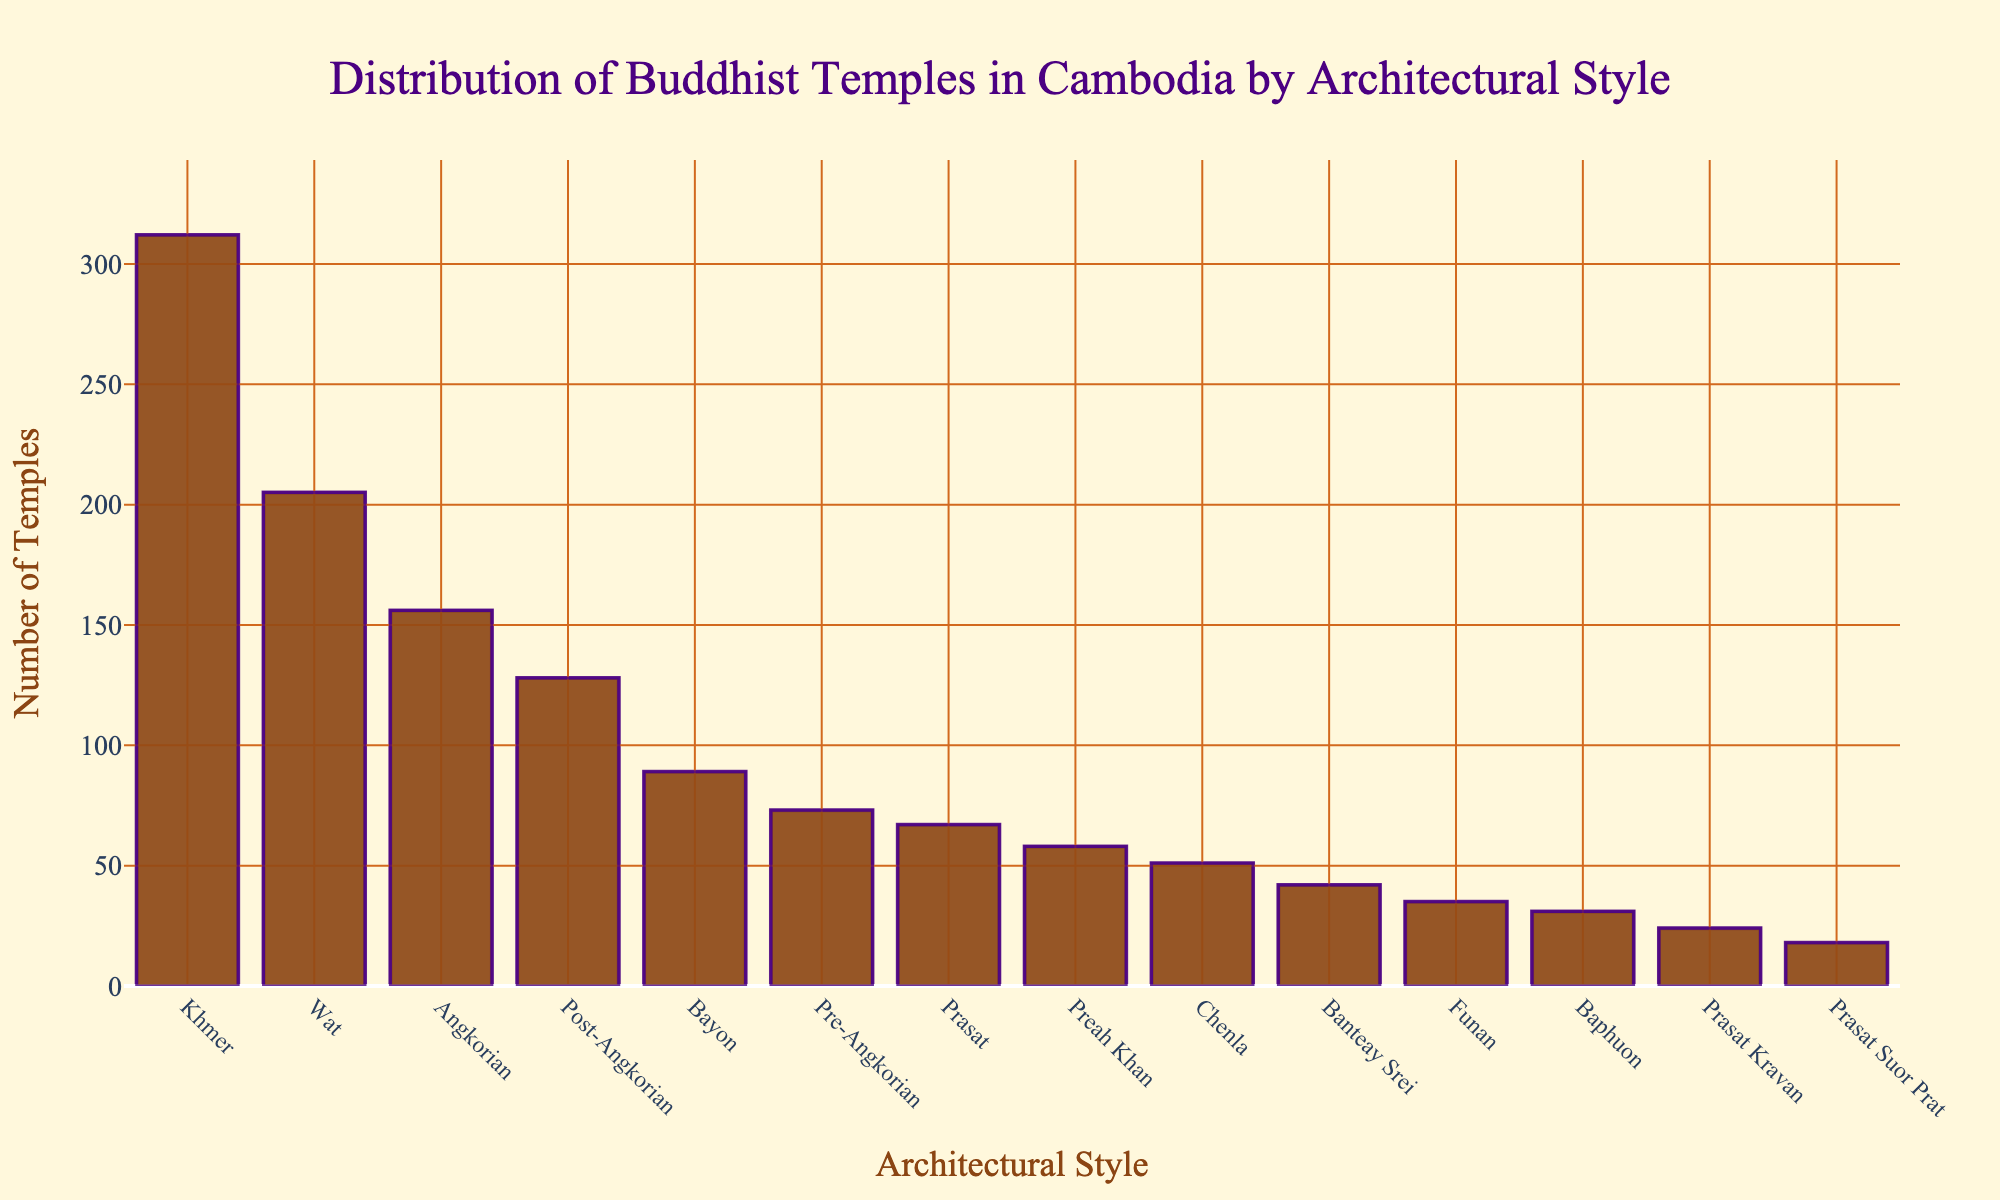Which architectural style has the highest number of temples? The bar representing "Khmer" architectural style is the tallest, indicating it has the highest number of temples.
Answer: Khmer Which two architectural styles have the closest number of temples? By observing the bar heights, "Chenla" and "Baphuon" have similar bar lengths, and both have a similar number of temples.
Answer: Chenla and Baphuon What's the total number of temples for Pre-Angkorian, Post-Angkorian, and Prasat styles combined? Sum the numbers of temples for each style: Pre-Angkorian (73), Post-Angkorian (128), and Prasat (67). 73 + 128 + 67 = 268.
Answer: 268 Which architectural style has more temples: Angkorian or Wat? Compare the heights of the bars for "Angkorian" and "Wat". The Wat bar is taller.
Answer: Wat How many architectural styles have more than 100 temples? Count the bars that exceed the 100 mark on the y-axis: Khmer, Angkorian, Wat, and Post-Angkorian.
Answer: 4 Which architectural style has the least number of temples? The "Prasat Suor Prat" bar is the shortest, indicating the fewest temples.
Answer: Prasat Suor Prat Are there more temples with Bayon style or Banteay Srei style? Compare the bar heights for "Bayon" and "Banteay Srei". The Bayon bar is taller.
Answer: Bayon What's the difference in the number of temples between the Khmer and Funan styles? Subtract the number of Funan temples from the number of Khmer temples: 312 - 35 = 277.
Answer: 277 